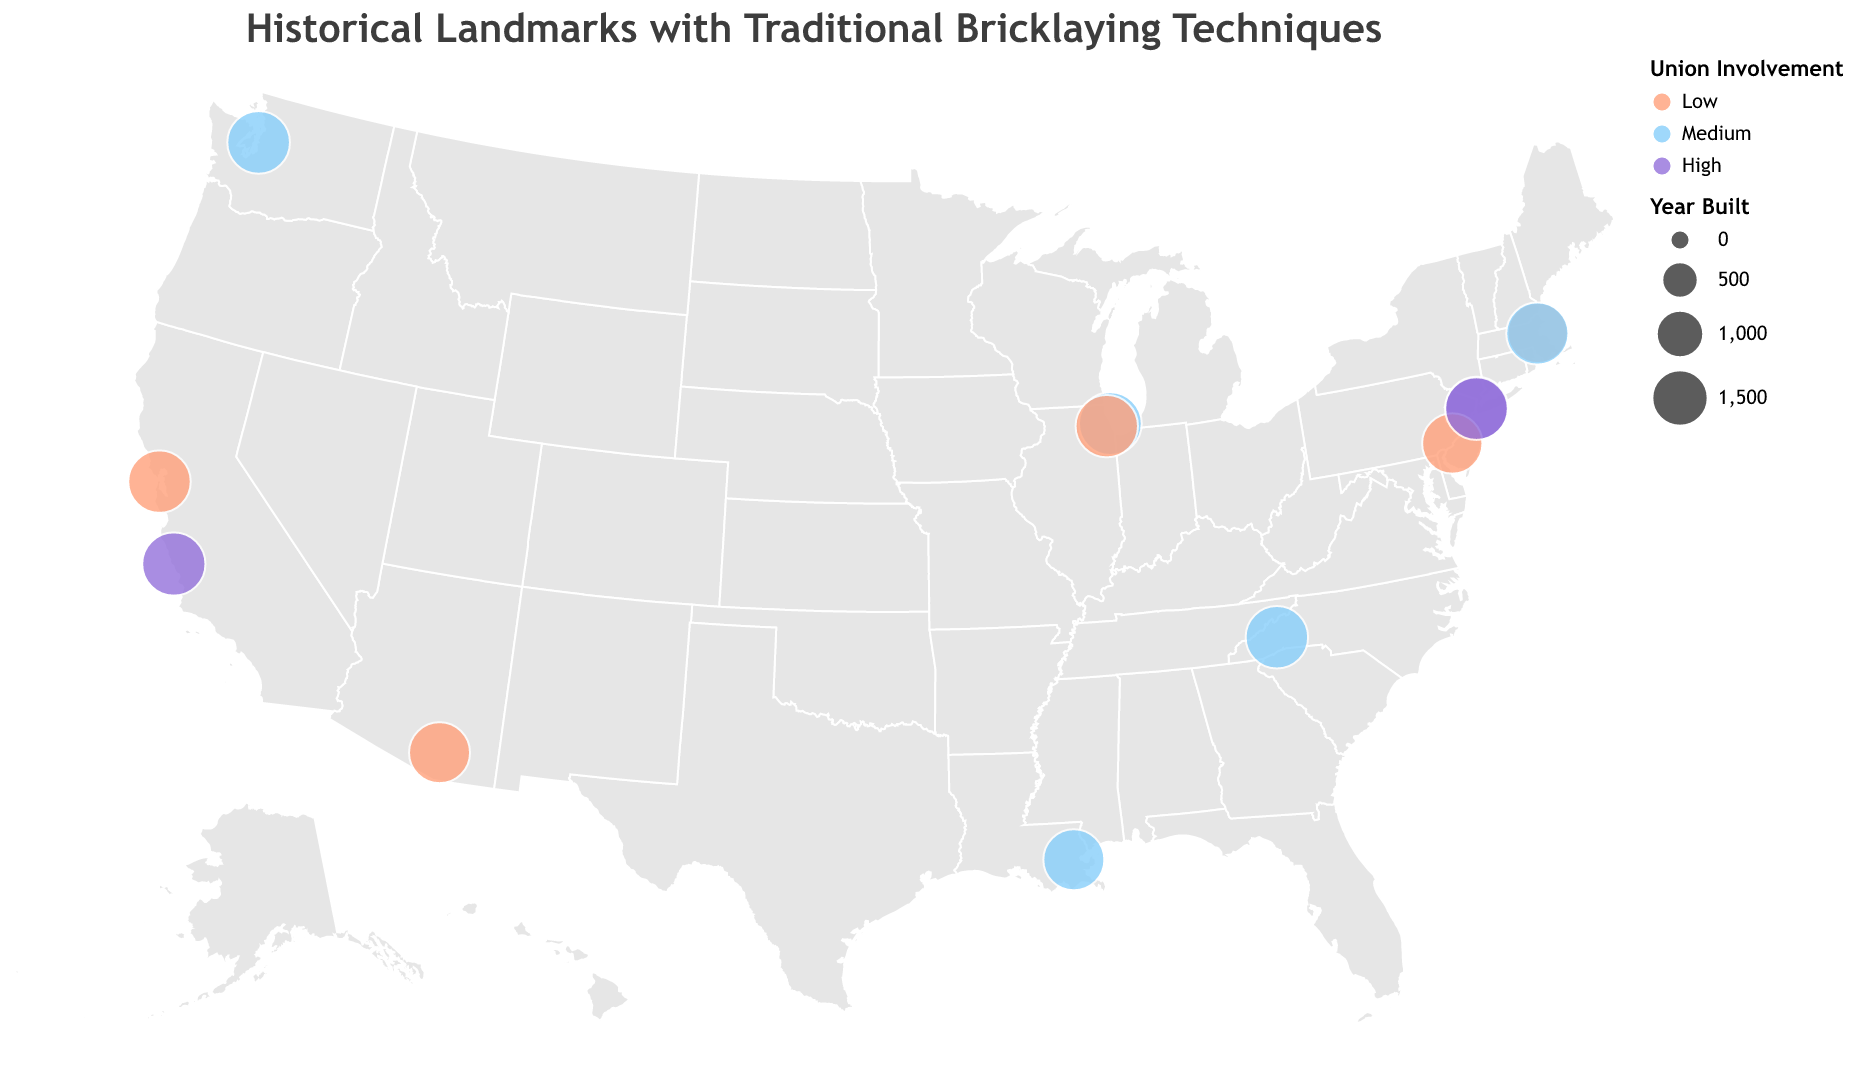What's the title of the figure? The title of the figure is displayed at the top; it's "Historical Landmarks with Traditional Bricklaying Techniques."
Answer: Historical Landmarks with Traditional Bricklaying Techniques How many different levels of union involvement are depicted in the figure? By examining the legend on the right side of the figure, you can see there are three different levels of union involvement: Low, Medium, and High.
Answer: Three What is the location of the landmark that uses the Beaux-Arts architectural style? The tooltip shows the specific details when hovering over the landmarks. For the Beaux-Arts style, it points to New York, NY (the Flatiron Building).
Answer: New York, NY Which landmark has the earliest construction year, and in which city is it located? Looking at the sizes of the circles (where smaller sizes indicate earlier construction years), and using the tooltip for verification, the French Quarter in New Orleans, LA, was built between 1718 and early 1800s.
Answer: French Quarter, New Orleans, LA What color represents "Medium Union Involvement" in the figure? The legend on the right side of the plot uses colors to indicate union involvement levels. "Medium Union Involvement" is marked with a light blue color.
Answer: Light Blue Compare the union involvement level in New York landmarks. By examining the figure's tooltip data for New York landmarks, you'll find that both the Chrysler Building and Flatiron Building have "High" union involvement.
Answer: High Among the Boston landmarks, which one was built earlier? The two Boston landmarks are Faneuil Hall and Trinity Church. The size of the circles shows the construction years. Faneuil Hall has a smaller circle, meaning it was built earlier in 1742.
Answer: Faneuil Hall Which landmark on the map is represented with the largest circle size, and what year was it built? The largest circle size on the figure represents the most recently built structures. Hovering over it, the tooltip shows Hearst Castle in San Simeon, CA, built in 1947.
Answer: Hearst Castle, built in 1947 Which architectural style has the highest representation on the map, and how many landmarks are of this style? By reviewing the legend and using the tooltip, you need to count the occurrences of each architectural style. Georgian style occurs twice (Independence Hall and Faneuil Hall).
Answer: Georgian, 2 